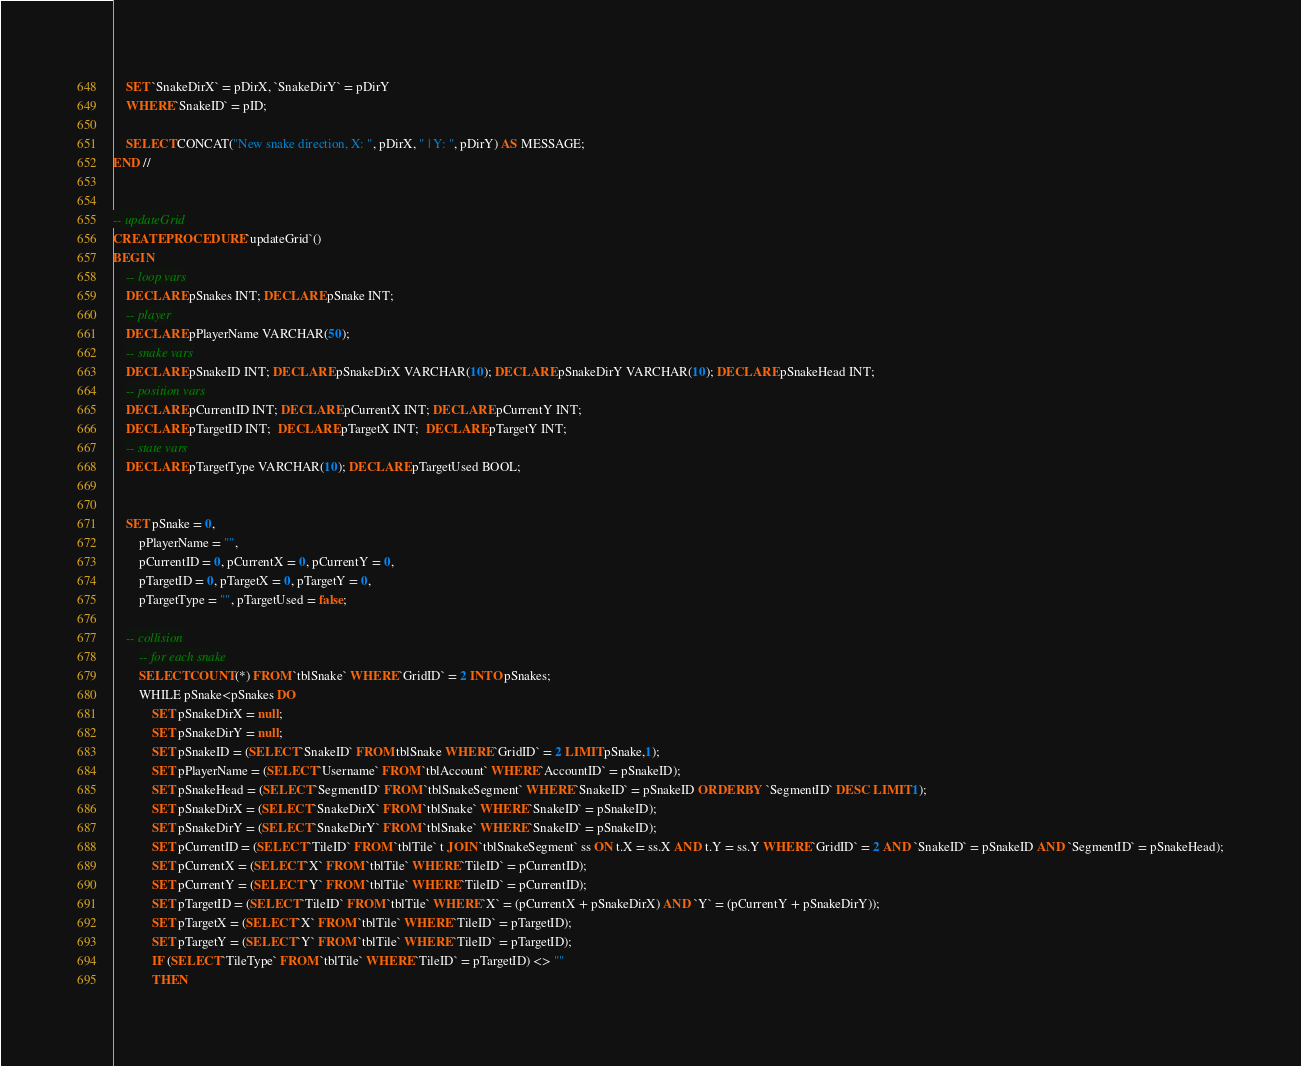<code> <loc_0><loc_0><loc_500><loc_500><_SQL_>    SET `SnakeDirX` = pDirX, `SnakeDirY` = pDirY
    WHERE `SnakeID` = pID;
    
    SELECT CONCAT("New snake direction, X: ", pDirX, " | Y: ", pDirY) AS MESSAGE;
END //


-- updateGrid
CREATE PROCEDURE `updateGrid`()
BEGIN
	-- loop vars
    DECLARE pSnakes INT; DECLARE pSnake INT;
    -- player
    DECLARE pPlayerName VARCHAR(50);
    -- snake vars
    DECLARE pSnakeID INT; DECLARE pSnakeDirX VARCHAR(10); DECLARE pSnakeDirY VARCHAR(10); DECLARE pSnakeHead INT;
    -- position vars
    DECLARE pCurrentID INT; DECLARE pCurrentX INT; DECLARE pCurrentY INT;
    DECLARE pTargetID INT;  DECLARE pTargetX INT;  DECLARE pTargetY INT;
    -- state vars
    DECLARE pTargetType VARCHAR(10); DECLARE pTargetUsed BOOL;
    
    
	SET pSnake = 0,
		pPlayerName = "",
		pCurrentID = 0, pCurrentX = 0, pCurrentY = 0,
		pTargetID = 0, pTargetX = 0, pTargetY = 0,
        pTargetType = "", pTargetUsed = false;
	
	-- collision
        -- for each snake
        SELECT COUNT(*) FROM `tblSnake` WHERE `GridID` = 2 INTO pSnakes;
        WHILE pSnake<pSnakes DO
			SET pSnakeDirX = null;
			SET pSnakeDirY = null;
			SET pSnakeID = (SELECT `SnakeID` FROM tblSnake WHERE `GridID` = 2 LIMIT pSnake,1);
            SET pPlayerName = (SELECT `Username` FROM `tblAccount` WHERE `AccountID` = pSnakeID);
			SET pSnakeHead = (SELECT `SegmentID` FROM `tblSnakeSegment` WHERE `SnakeID` = pSnakeID ORDER BY `SegmentID` DESC LIMIT 1);
            SET pSnakeDirX = (SELECT `SnakeDirX` FROM `tblSnake` WHERE `SnakeID` = pSnakeID);
            SET pSnakeDirY = (SELECT `SnakeDirY` FROM `tblSnake` WHERE `SnakeID` = pSnakeID);
            SET pCurrentID = (SELECT `TileID` FROM `tblTile` t JOIN `tblSnakeSegment` ss ON t.X = ss.X AND t.Y = ss.Y WHERE `GridID` = 2 AND `SnakeID` = pSnakeID AND `SegmentID` = pSnakeHead);
            SET pCurrentX = (SELECT `X` FROM `tblTile` WHERE `TileID` = pCurrentID);
            SET pCurrentY = (SELECT `Y` FROM `tblTile` WHERE `TileID` = pCurrentID);
            SET pTargetID = (SELECT `TileID` FROM `tblTile` WHERE `X` = (pCurrentX + pSnakeDirX) AND `Y` = (pCurrentY + pSnakeDirY));
            SET pTargetX = (SELECT `X` FROM `tblTile` WHERE `TileID` = pTargetID);
            SET pTargetY = (SELECT `Y` FROM `tblTile` WHERE `TileID` = pTargetID);
            IF (SELECT `TileType` FROM `tblTile` WHERE `TileID` = pTargetID) <> ""
            THEN</code> 